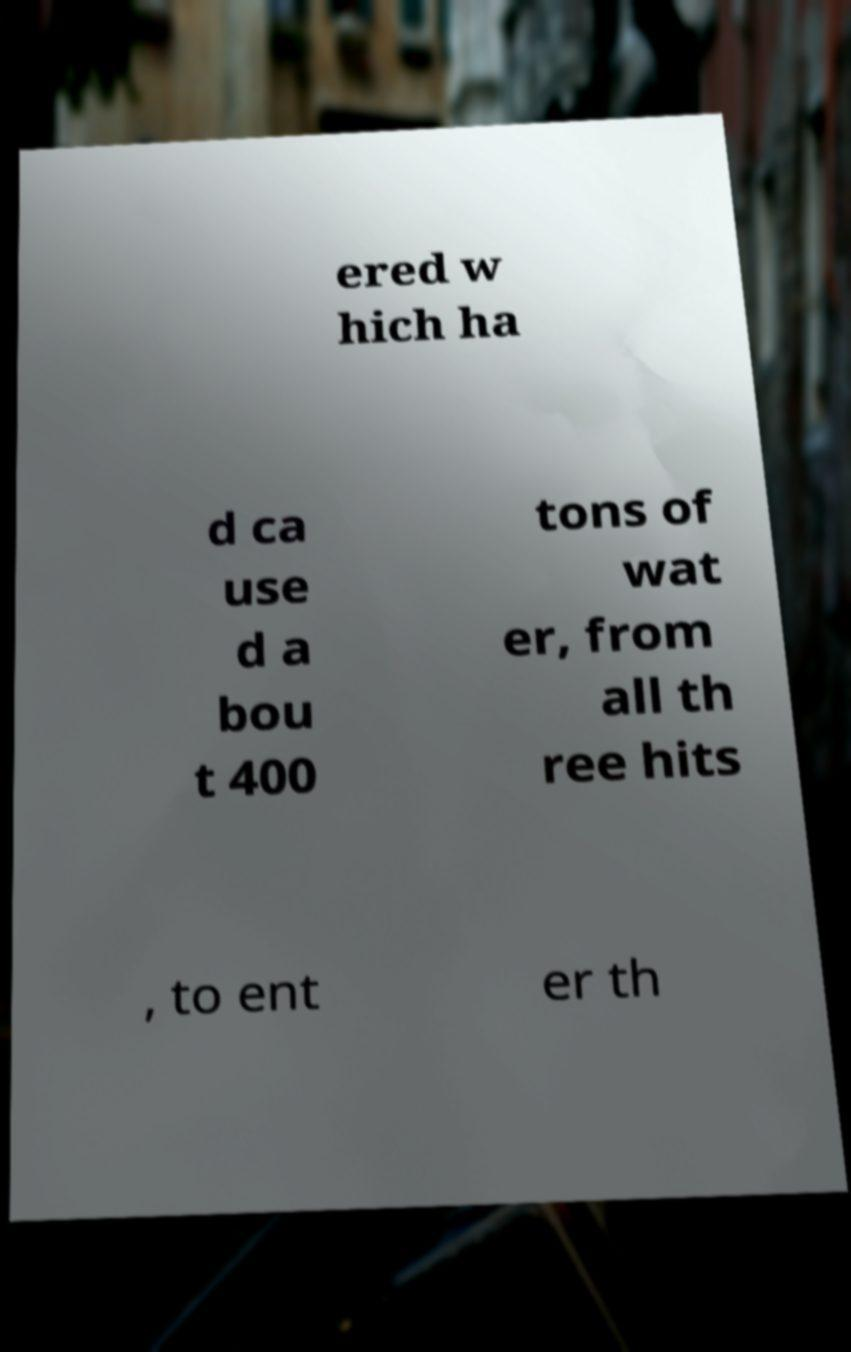Please identify and transcribe the text found in this image. ered w hich ha d ca use d a bou t 400 tons of wat er, from all th ree hits , to ent er th 